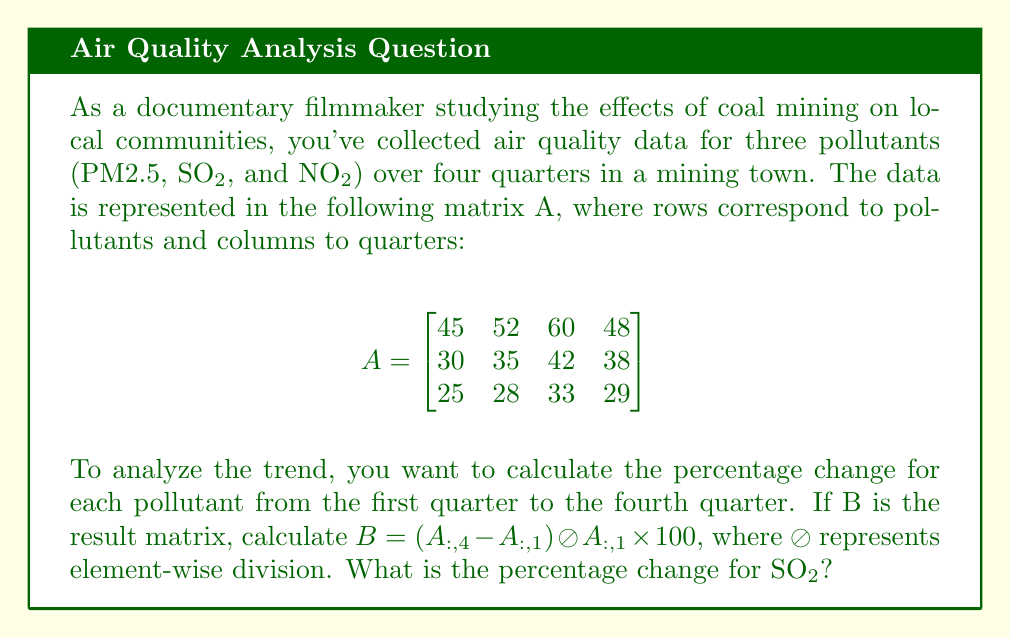Provide a solution to this math problem. Let's approach this step-by-step:

1) First, we need to extract the first and fourth columns of matrix A:

   $A_{:,1} = \begin{bmatrix} 45 \\ 30 \\ 25 \end{bmatrix}$ (first quarter)
   
   $A_{:,4} = \begin{bmatrix} 48 \\ 38 \\ 29 \end{bmatrix}$ (fourth quarter)

2) Now, we calculate $A_{:,4} - A_{:,1}$:

   $A_{:,4} - A_{:,1} = \begin{bmatrix} 48 \\ 38 \\ 29 \end{bmatrix} - \begin{bmatrix} 45 \\ 30 \\ 25 \end{bmatrix} = \begin{bmatrix} 3 \\ 8 \\ 4 \end{bmatrix}$

3) Next, we perform element-wise division by $A_{:,1}$:

   $(A_{:,4} - A_{:,1}) \oslash A_{:,1} = \begin{bmatrix} 3/45 \\ 8/30 \\ 4/25 \end{bmatrix}$

4) Finally, we multiply by 100 to get the percentage:

   $B = (A_{:,4} - A_{:,1}) \oslash A_{:,1} \times 100 = \begin{bmatrix} (3/45) \times 100 \\ (8/30) \times 100 \\ (4/25) \times 100 \end{bmatrix} = \begin{bmatrix} 6.67 \\ 26.67 \\ 16 \end{bmatrix}$

5) The second row of the result matrix B corresponds to SO2. Therefore, the percentage change for SO2 is 26.67%.
Answer: 26.67% 